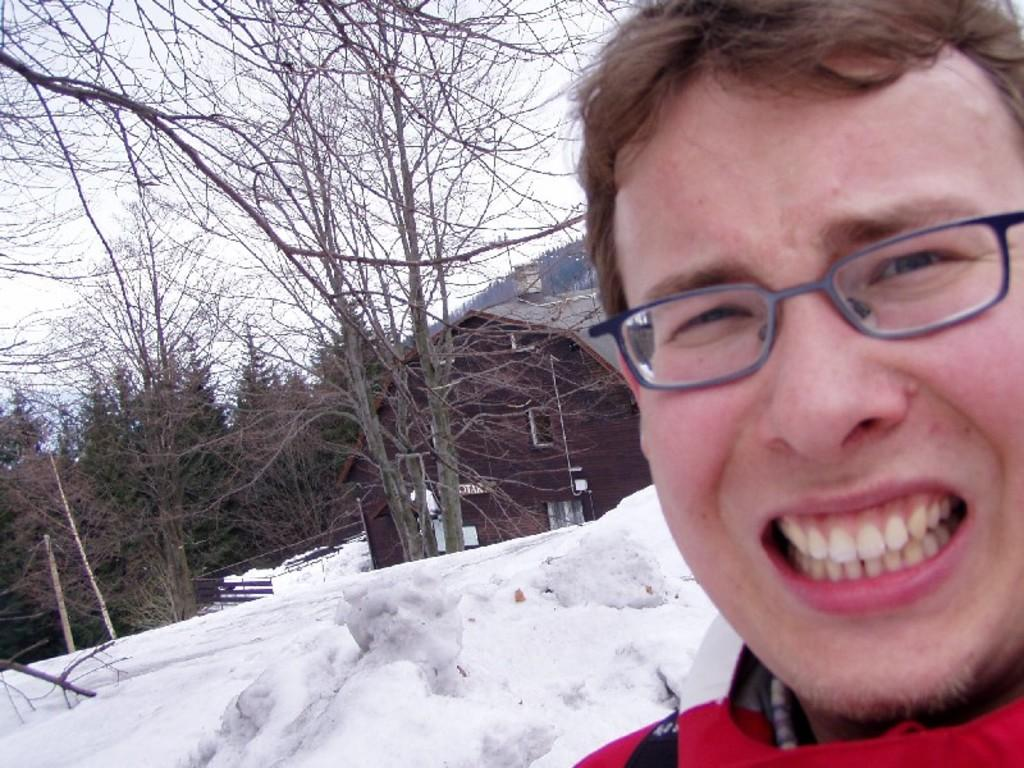What is the main feature of the landscape in the image? There is snow in the image. What type of natural elements can be seen in the image? There are trees in the image. What can be seen in the sky in the image? The sky is visible in the image. Who is present in the image? There is a man in the image. What is the man wearing? The man is wearing a red jacket. How far away is the cow from the man in the image? There is no cow present in the image. What is the man doing to his throat in the image? The man is not doing anything to his throat in the image; he is simply standing there wearing a red jacket. 